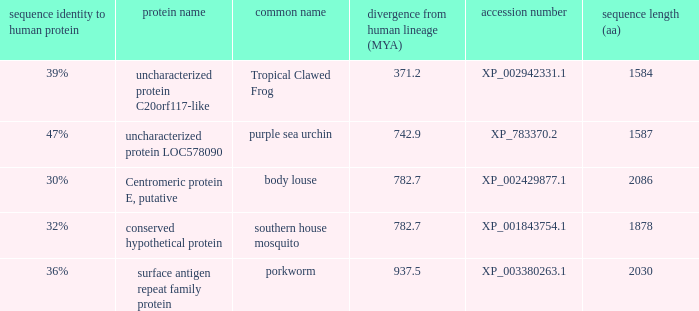What is the sequence length (aa) of the protein with the common name Purple Sea Urchin and a divergence from human lineage less than 742.9? None. 